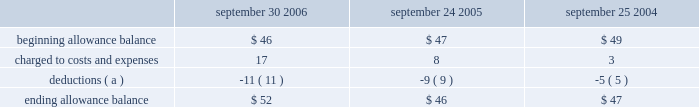Notes to consolidated financial statements ( continued ) note 3 2014financial instruments ( continued ) accounts receivable trade receivables the company distributes its products through third-party distributors and resellers and directly to certain education , consumer , and commercial customers .
The company generally does not require collateral from its customers ; however , the company will require collateral in certain instances to limit credit risk .
In addition , when possible , the company does attempt to limit credit risk on trade receivables with credit insurance for certain customers in latin america , europe , asia , and australia and by arranging with third- party financing companies to provide flooring arrangements and other loan and lease programs to the company 2019s direct customers .
These credit-financing arrangements are directly between the third-party financing company and the end customer .
As such , the company generally does not assume any recourse or credit risk sharing related to any of these arrangements .
However , considerable trade receivables that are not covered by collateral , third-party flooring arrangements , or credit insurance are outstanding with the company 2019s distribution and retail channel partners .
No customer accounted for more than 10% ( 10 % ) of trade receivables as of september 30 , 2006 or september 24 , 2005 .
The table summarizes the activity in the allowance for doubtful accounts ( in millions ) : september 30 , september 24 , september 25 .
( a ) represents amounts written off against the allowance , net of recoveries .
Vendor non-trade receivables the company has non-trade receivables from certain of its manufacturing vendors resulting from the sale of raw material components to these manufacturing vendors who manufacture sub-assemblies or assemble final products for the company .
The company purchases these raw material components directly from suppliers .
These non-trade receivables , which are included in the consolidated balance sheets in other current assets , totaled $ 1.6 billion and $ 417 million as of september 30 , 2006 and september 24 , 2005 , respectively .
The company does not reflect the sale of these components in net sales and does not recognize any profits on these sales until the products are sold through to the end customer at which time the profit is recognized as a reduction of cost of sales .
Derivative financial instruments the company uses derivatives to partially offset its business exposure to foreign exchange risk .
Foreign currency forward and option contracts are used to offset the foreign exchange risk on certain existing assets and liabilities and to hedge the foreign exchange risk on expected future cash flows on certain forecasted revenue and cost of sales .
From time to time , the company enters into interest rate derivative agreements to modify the interest rate profile of certain investments and debt .
The company 2019s accounting policies for these instruments are based on whether the instruments are designated as hedge or non-hedge instruments .
The company records all derivatives on the balance sheet at fair value. .
By how much did the allowance for doubtful accounts increase from 2005 to 2006? 
Computations: ((52 - 46) / 46)
Answer: 0.13043. Notes to consolidated financial statements ( continued ) note 3 2014financial instruments ( continued ) accounts receivable trade receivables the company distributes its products through third-party distributors and resellers and directly to certain education , consumer , and commercial customers .
The company generally does not require collateral from its customers ; however , the company will require collateral in certain instances to limit credit risk .
In addition , when possible , the company does attempt to limit credit risk on trade receivables with credit insurance for certain customers in latin america , europe , asia , and australia and by arranging with third- party financing companies to provide flooring arrangements and other loan and lease programs to the company 2019s direct customers .
These credit-financing arrangements are directly between the third-party financing company and the end customer .
As such , the company generally does not assume any recourse or credit risk sharing related to any of these arrangements .
However , considerable trade receivables that are not covered by collateral , third-party flooring arrangements , or credit insurance are outstanding with the company 2019s distribution and retail channel partners .
No customer accounted for more than 10% ( 10 % ) of trade receivables as of september 30 , 2006 or september 24 , 2005 .
The table summarizes the activity in the allowance for doubtful accounts ( in millions ) : september 30 , september 24 , september 25 .
( a ) represents amounts written off against the allowance , net of recoveries .
Vendor non-trade receivables the company has non-trade receivables from certain of its manufacturing vendors resulting from the sale of raw material components to these manufacturing vendors who manufacture sub-assemblies or assemble final products for the company .
The company purchases these raw material components directly from suppliers .
These non-trade receivables , which are included in the consolidated balance sheets in other current assets , totaled $ 1.6 billion and $ 417 million as of september 30 , 2006 and september 24 , 2005 , respectively .
The company does not reflect the sale of these components in net sales and does not recognize any profits on these sales until the products are sold through to the end customer at which time the profit is recognized as a reduction of cost of sales .
Derivative financial instruments the company uses derivatives to partially offset its business exposure to foreign exchange risk .
Foreign currency forward and option contracts are used to offset the foreign exchange risk on certain existing assets and liabilities and to hedge the foreign exchange risk on expected future cash flows on certain forecasted revenue and cost of sales .
From time to time , the company enters into interest rate derivative agreements to modify the interest rate profile of certain investments and debt .
The company 2019s accounting policies for these instruments are based on whether the instruments are designated as hedge or non-hedge instruments .
The company records all derivatives on the balance sheet at fair value. .
What was the greatest ending allowance balance , in millions? 
Computations: table_max(ending allowance balance, none)
Answer: 52.0. 